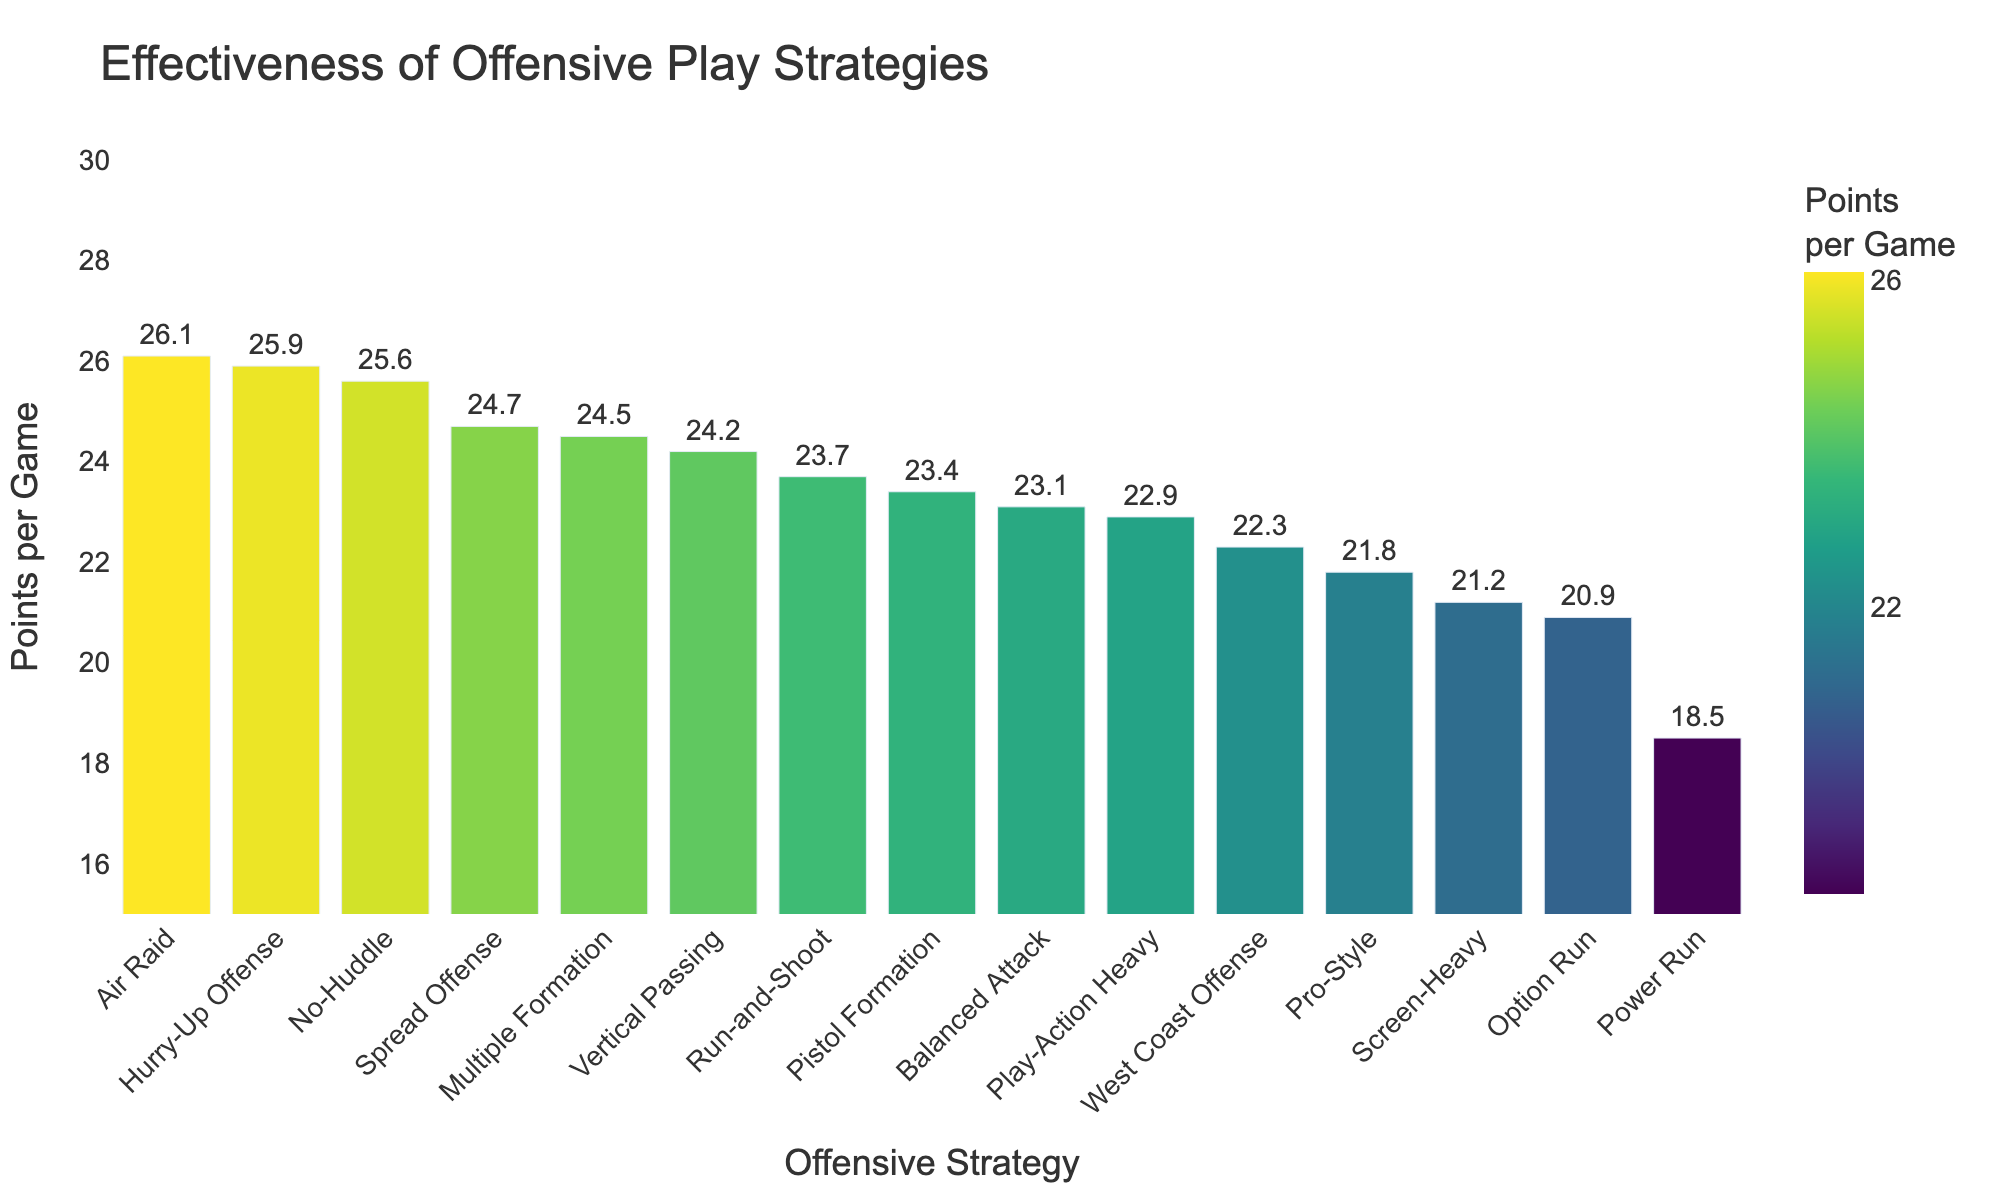Which offensive strategy has the highest average points per game? The highest bar represents the strategy with the highest average points per game. The "Air Raid" strategy has the highest bar, indicating it has the highest average points per game.
Answer: Air Raid Which strategy has a higher points per game, Pro-Style or Option Run? Locate the bars for both "Pro-Style" and "Option Run" strategies and compare their heights. "Option Run" has 20.9 points per game and "Pro-Style" has 21.8 points per game. Pro-Style's bar is taller, so it has a higher points per game.
Answer: Pro-Style How much greater is the points per game of No-Huddle compared to West Coast Offense? Find the No-Huddle and West Coast Offense bars, and note their points per game: No-Huddle (25.6) and West Coast Offense (22.3). Subtract the lower value from the higher value: 25.6 - 22.3.
Answer: 3.3 Which two strategies have the smallest difference in points per game? Find the pair of bars that are closest in height. Upon inspection, "Pistol Formation" (23.4) and "Run-and-Shoot" (23.7) have the smallest difference in points per game.
Answer: Pistol Formation and Run-and-Shoot What is the average points per game of the top three scoring strategies? Identify the top three strategies: "Air Raid" (26.1), "Hurry-Up Offense" (25.9), and "No-Huddle" (25.6). Calculate their average: (26.1 + 25.9 + 25.6) / 3.
Answer: 25.87 Which strategy has the lowest points per game, and what is its value? The shortest bar represents the strategy with the lowest points per game. "Power Run" has the shortest bar with 18.5 points per game.
Answer: Power Run, 18.5 What is the total sum of points per game for the strategies Pro-Style, Vertical Passing, and Screen-Heavy? Identify the points per game for each strategy: Pro-Style (21.8), Vertical Passing (24.2), and Screen-Heavy (21.2). Sum these values: 21.8 + 24.2 + 21.2.
Answer: 67.2 Which strategy is colored the darkest in the plot? The color intensity increases with the points per game. The strategy with the darkest color is the one with the least points per game. "Power Run" strategy has the darkest shade.
Answer: Power Run How does the points per game of Spread Offense compare to Balanced Attack? Identify the bars for Spread Offense and Balanced Attack. Spread Offense has 24.7 points per game, and Balanced Attack has 23.1 points per game. Spread Offense’s value is greater.
Answer: Spread Offense What is the median value of points per game across all strategies shown? List the points per game for all strategies and order them: [18.5, 20.9, 21.2, 21.8, 22.3, 22.9, 23.1, 23.4, 23.7, 24.2, 24.5, 24.7, 25.6, 25.9, 26.1]. The median value (8th in ordered list) is 23.4.
Answer: 23.4 